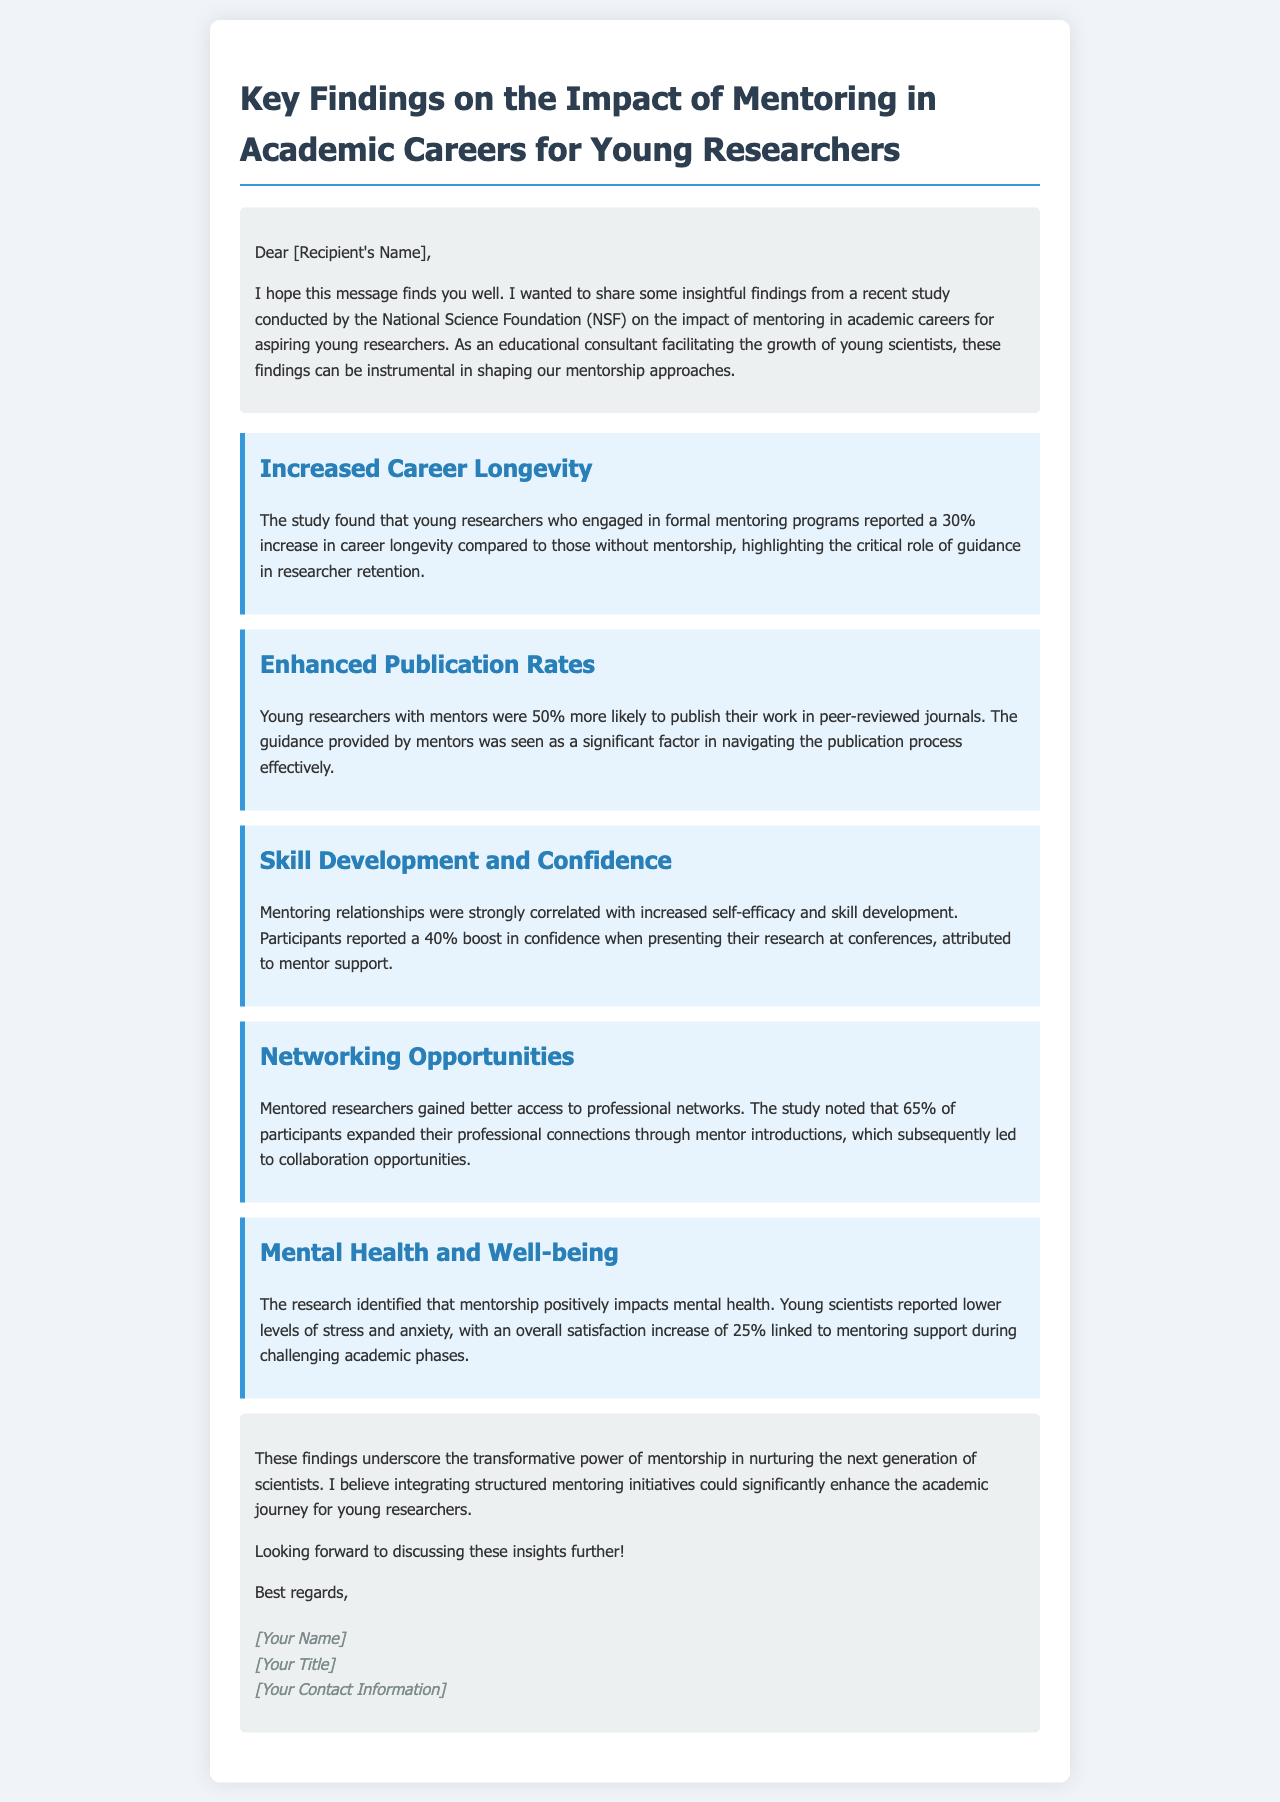What is the percentage increase in career longevity for young researchers who engaged in mentoring programs? The study found a 30% increase in career longevity for those with mentorship.
Answer: 30% How much more likely are young researchers with mentors to publish their work? Young researchers with mentors were 50% more likely to publish their work in peer-reviewed journals.
Answer: 50% What percentage of participants reported a boost in confidence due to mentorship? Participants reported a 40% boost in confidence attributed to mentor support.
Answer: 40% What is the main positive impact of mentoring on mental health reported in the study? Young scientists reported lower levels of stress and anxiety linked to mentoring support.
Answer: Lower levels of stress and anxiety What proportion of mentored researchers gained access to professional networks? The study noted that 65% of participants expanded their professional connections through mentor introductions.
Answer: 65% What is the overall satisfaction increase linked to mentoring support during challenging academic phases? An overall satisfaction increase of 25% was linked to mentoring support.
Answer: 25% Who conducted the study on mentoring impact? The study was conducted by the National Science Foundation (NSF).
Answer: National Science Foundation (NSF) What term describes the transformative effect of mentorship mentioned in the conclusion? The conclusion mentions the transformative power of mentorship.
Answer: Transformative power 